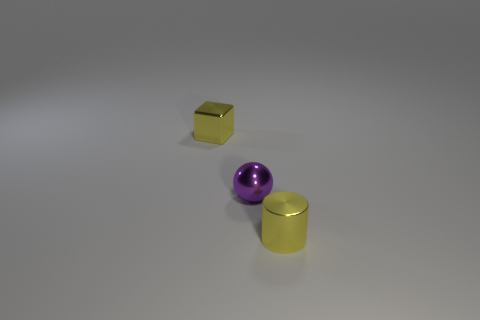Are there any metal objects of the same color as the metallic block?
Ensure brevity in your answer.  Yes. What material is the yellow cylinder?
Your response must be concise. Metal. How many things are purple metal objects or blue matte objects?
Make the answer very short. 1. There is a yellow object that is in front of the small purple shiny sphere; what size is it?
Offer a terse response. Small. There is a yellow thing to the left of the tiny ball; are there any yellow objects that are behind it?
Your answer should be compact. No. Is there any other thing that has the same shape as the purple metallic object?
Your response must be concise. No. What size is the block?
Your answer should be very brief. Small. Is the number of tiny purple shiny balls on the left side of the yellow metallic block less than the number of small blue metal balls?
Give a very brief answer. No. Do the purple ball and the yellow object in front of the small shiny cube have the same material?
Ensure brevity in your answer.  Yes. Is there a tiny purple object that is on the right side of the small yellow object to the right of the small yellow object that is left of the cylinder?
Ensure brevity in your answer.  No. 